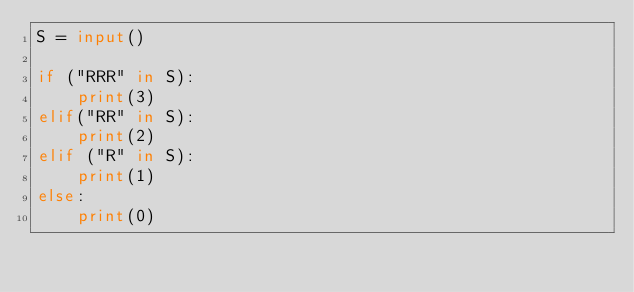<code> <loc_0><loc_0><loc_500><loc_500><_Python_>S = input()

if ("RRR" in S):
    print(3)
elif("RR" in S):
    print(2)
elif ("R" in S):
    print(1)
else:
    print(0)
</code> 